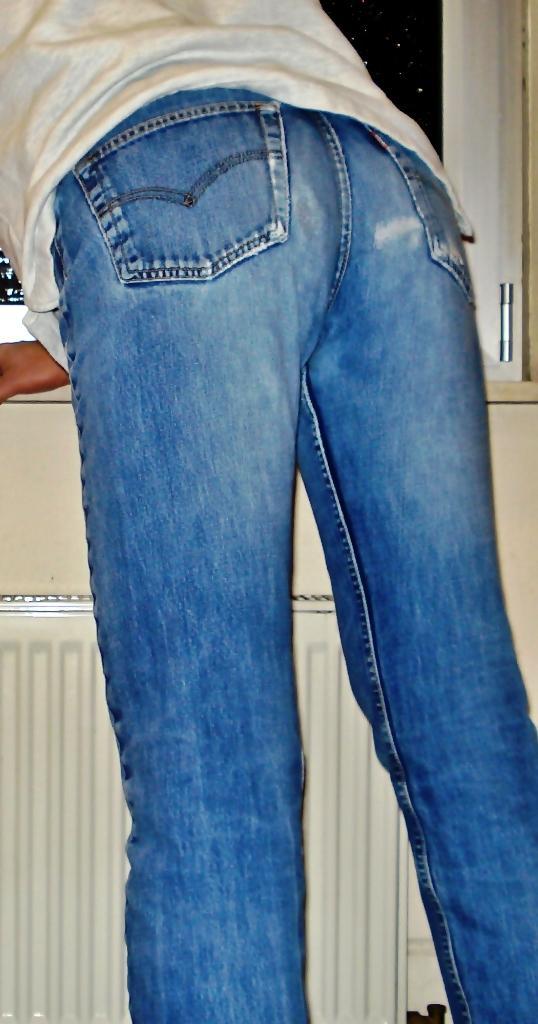Can you describe this image briefly? This image is taken indoors. In the background there is a window and there is a kitchen platform with a cupboard. In the middle of the image a person is standing. 